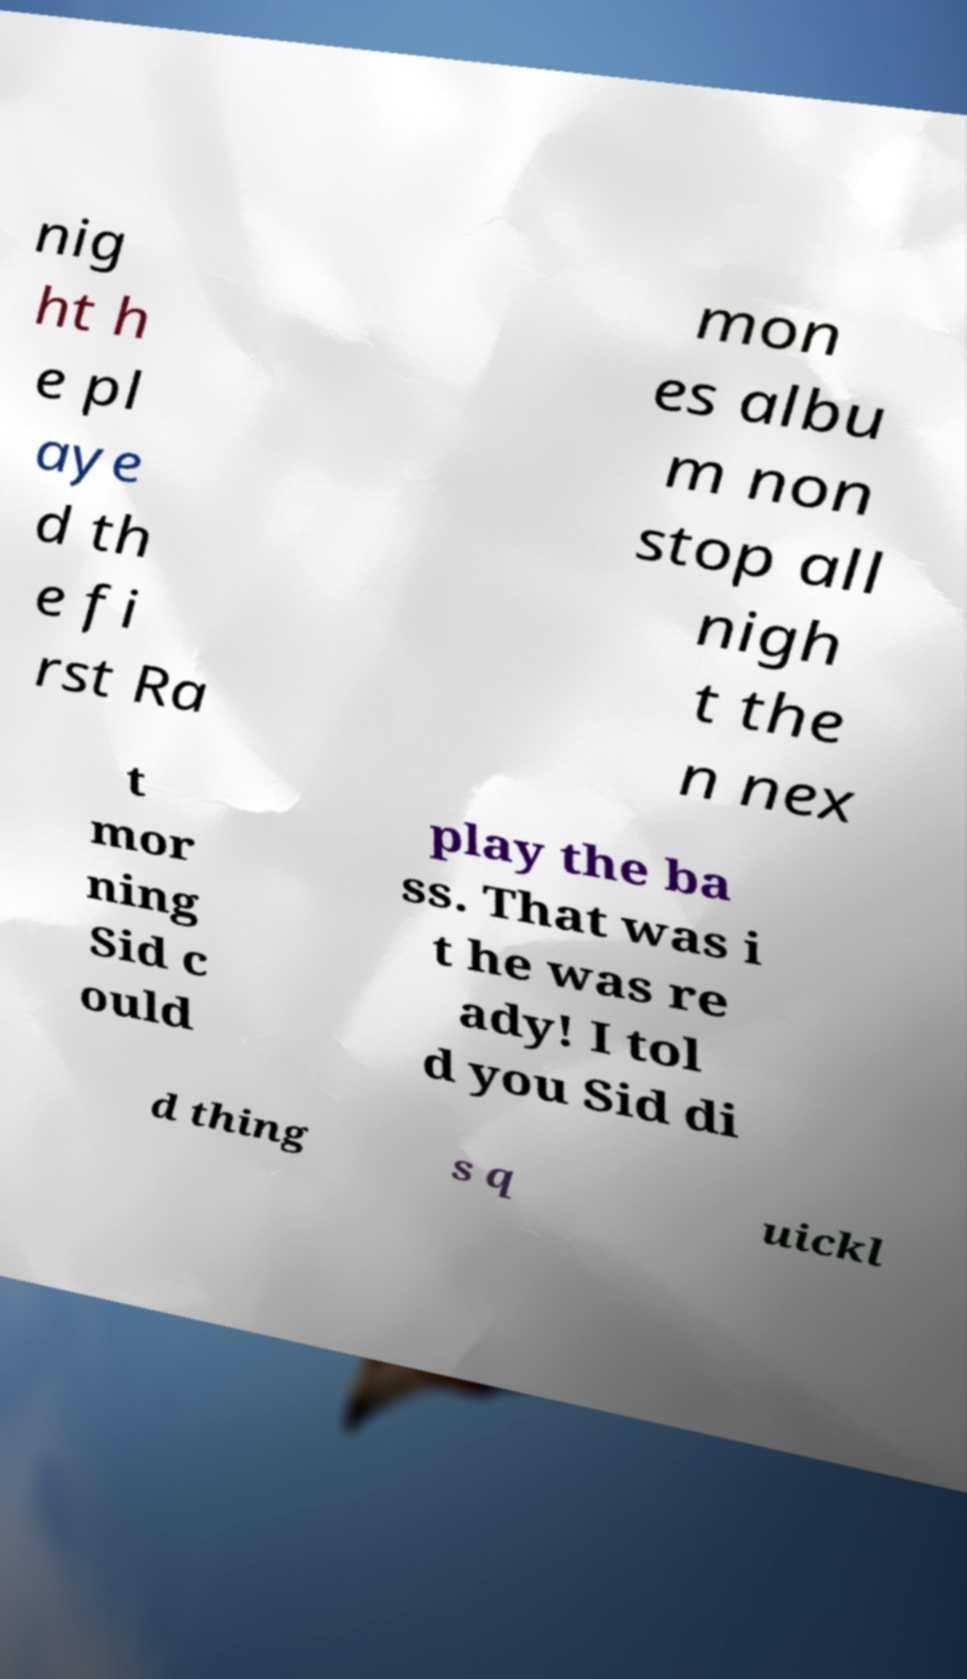What messages or text are displayed in this image? I need them in a readable, typed format. nig ht h e pl aye d th e fi rst Ra mon es albu m non stop all nigh t the n nex t mor ning Sid c ould play the ba ss. That was i t he was re ady! I tol d you Sid di d thing s q uickl 